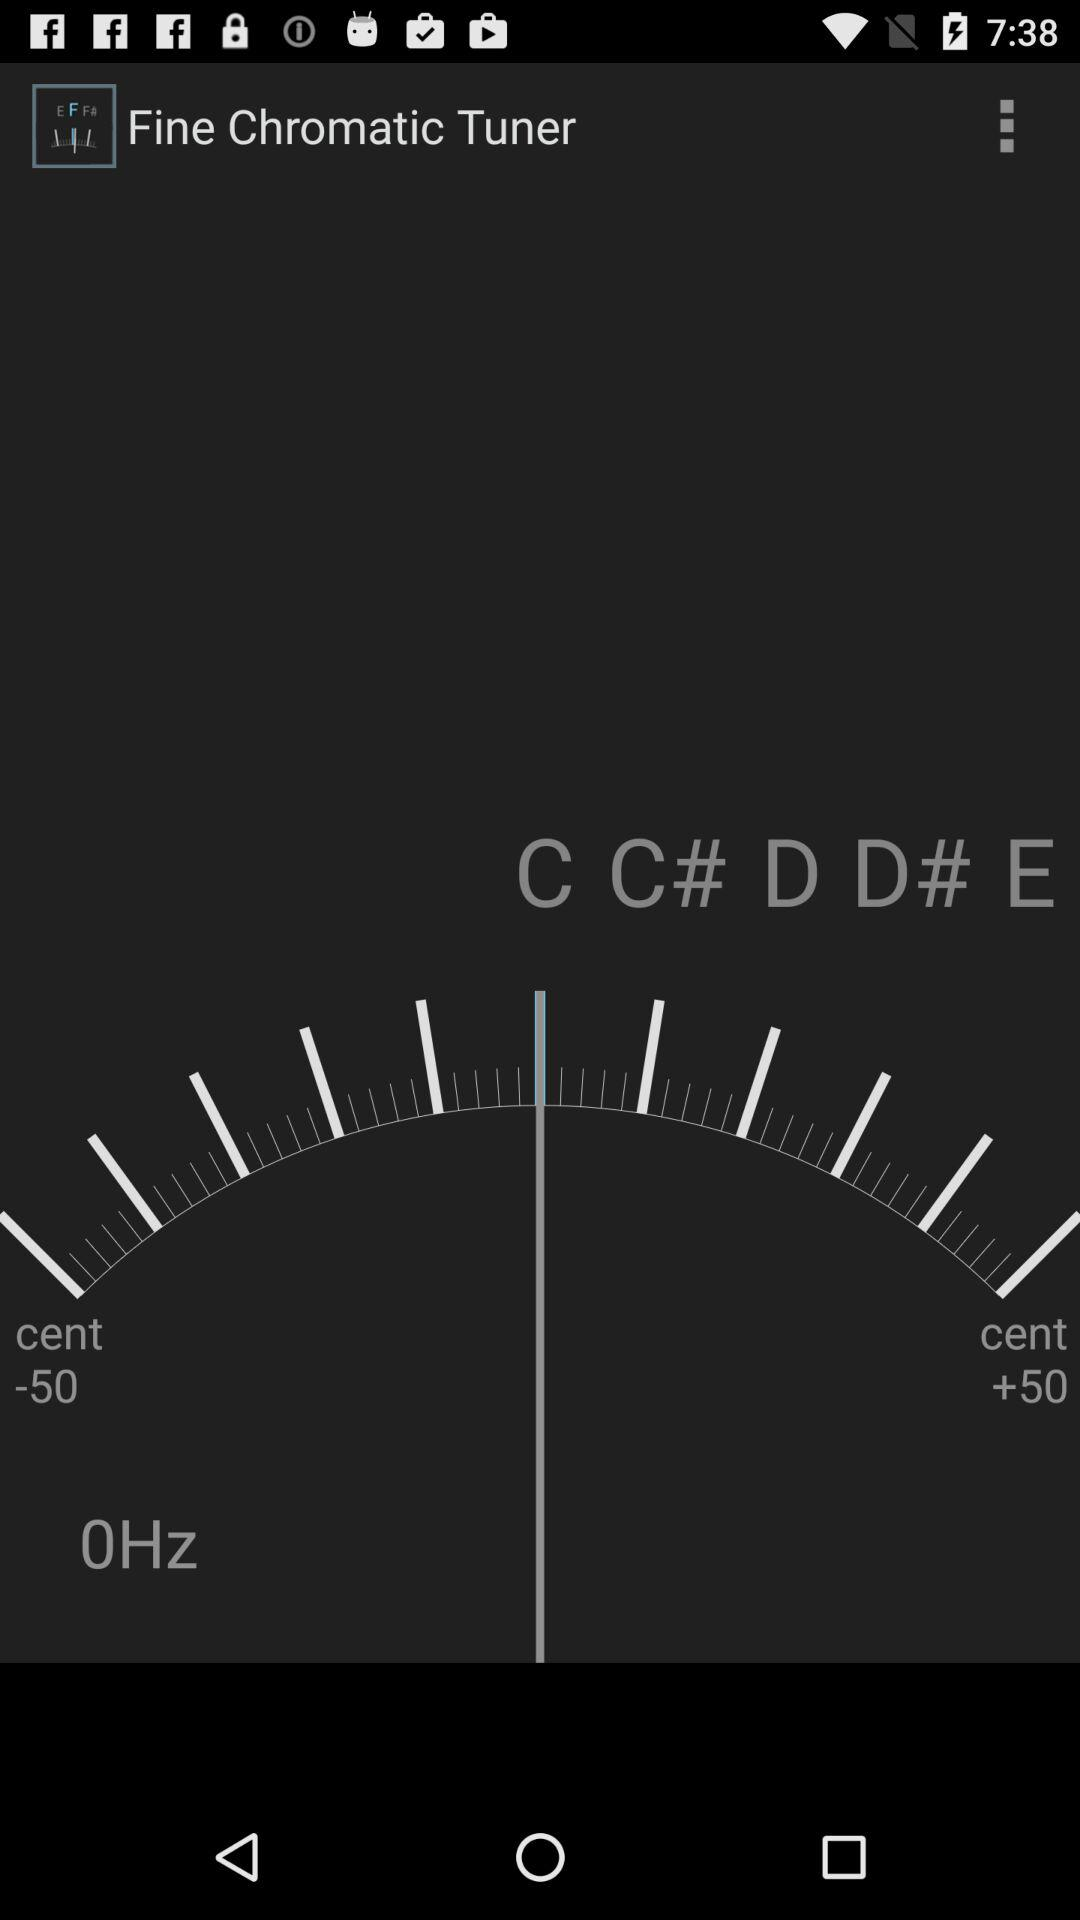How many notes are displayed on the screen?
Answer the question using a single word or phrase. 5 